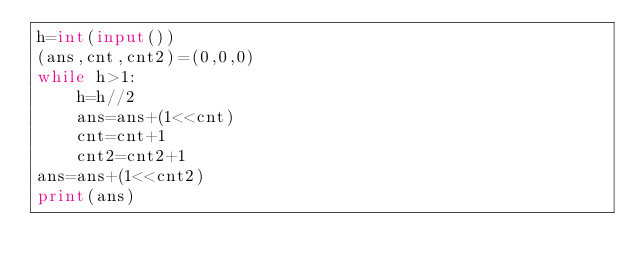Convert code to text. <code><loc_0><loc_0><loc_500><loc_500><_Python_>h=int(input())
(ans,cnt,cnt2)=(0,0,0)
while h>1:
	h=h//2
	ans=ans+(1<<cnt)
	cnt=cnt+1
	cnt2=cnt2+1
ans=ans+(1<<cnt2)
print(ans)</code> 